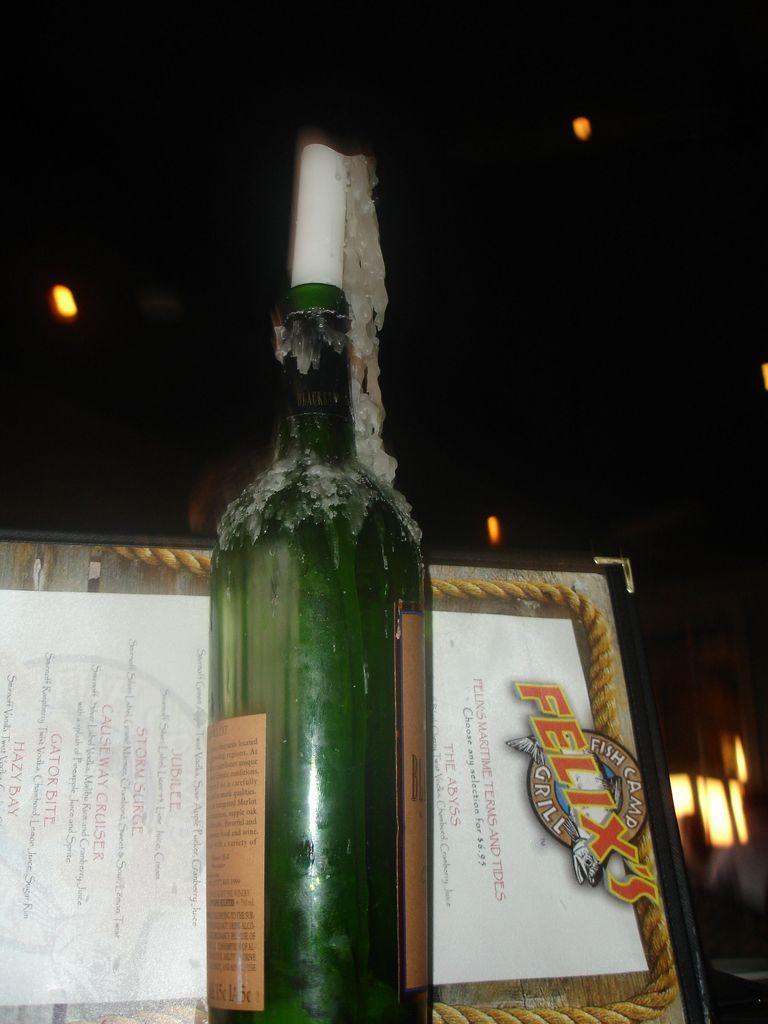What object can be seen in the image that might contain a liquid? There is a bottle in the image that might contain a liquid. What object can be seen in the image that might provide information about available items or services? There is a menu card in the image that might provide information about available items or services. What type of instrument is being played in the image? There is no instrument being played in the image; it only features a bottle and a menu card. Can you describe the battle scene depicted in the image? There is no battle scene present in the image; it only features a bottle and a menu card. 